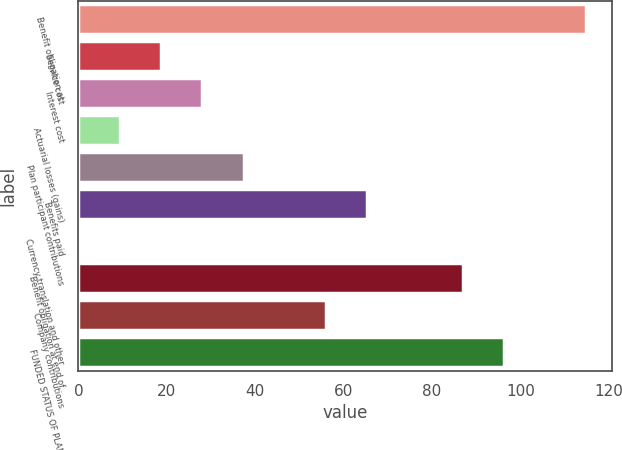Convert chart. <chart><loc_0><loc_0><loc_500><loc_500><bar_chart><fcel>Benefit obligation at<fcel>Service cost<fcel>Interest cost<fcel>Actuarial losses (gains)<fcel>Plan participant contributions<fcel>Benefits paid<fcel>Currency translation and other<fcel>Benefit obligation at end of<fcel>Company contributions<fcel>FUNDED STATUS OF PLANS<nl><fcel>114.86<fcel>18.74<fcel>28.06<fcel>9.42<fcel>37.38<fcel>65.34<fcel>0.1<fcel>86.9<fcel>56.02<fcel>96.22<nl></chart> 